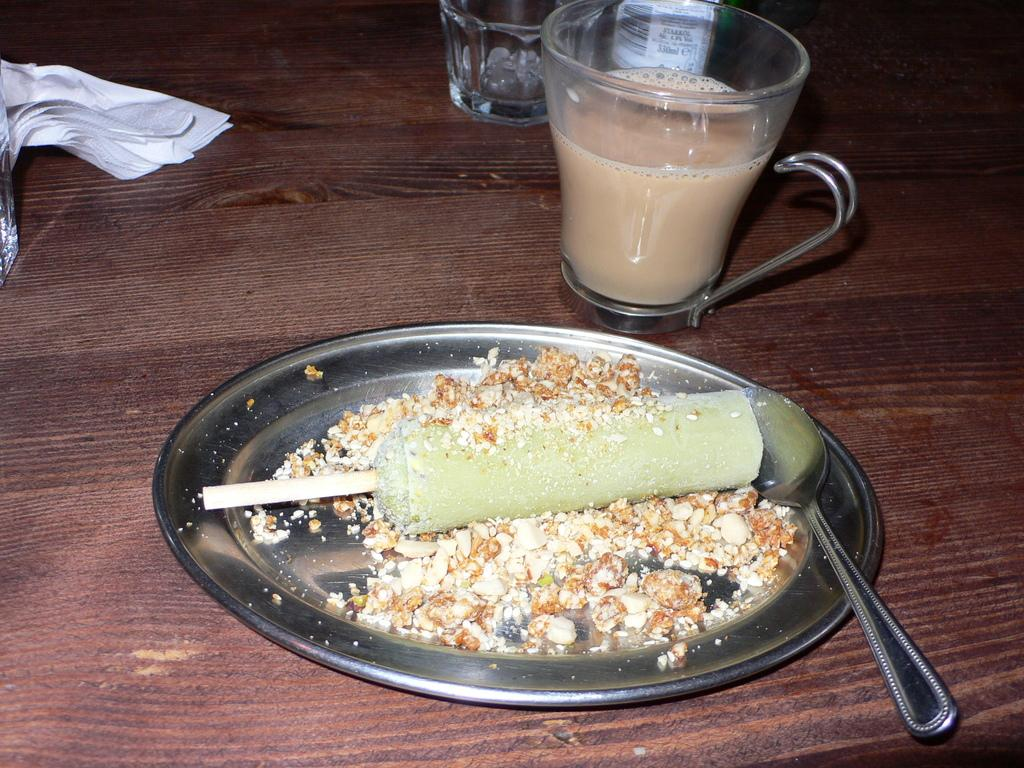What is on the plate in the image? There is a plate with food items in the image. What utensil is on the plate? There is a spoon on the plate. What can be found in the cup in the image? There is a cup with a drink in the image. What is the other container for a beverage in the image? There is a glass in the image. What type of container has a label in the image? There is a bottle with a label in the image. What is the material of the cloth in the image? The cloth in the image is not specified, but it is present. What is the table made of in the image? The table is made of wood. How many members are in the team that is playing with the hydrant in the image? There is no team or hydrant present in the image; it features a plate with food items, a spoon, a cup with a drink, a glass, a bottle with a label, a cloth, and a wooden table. 